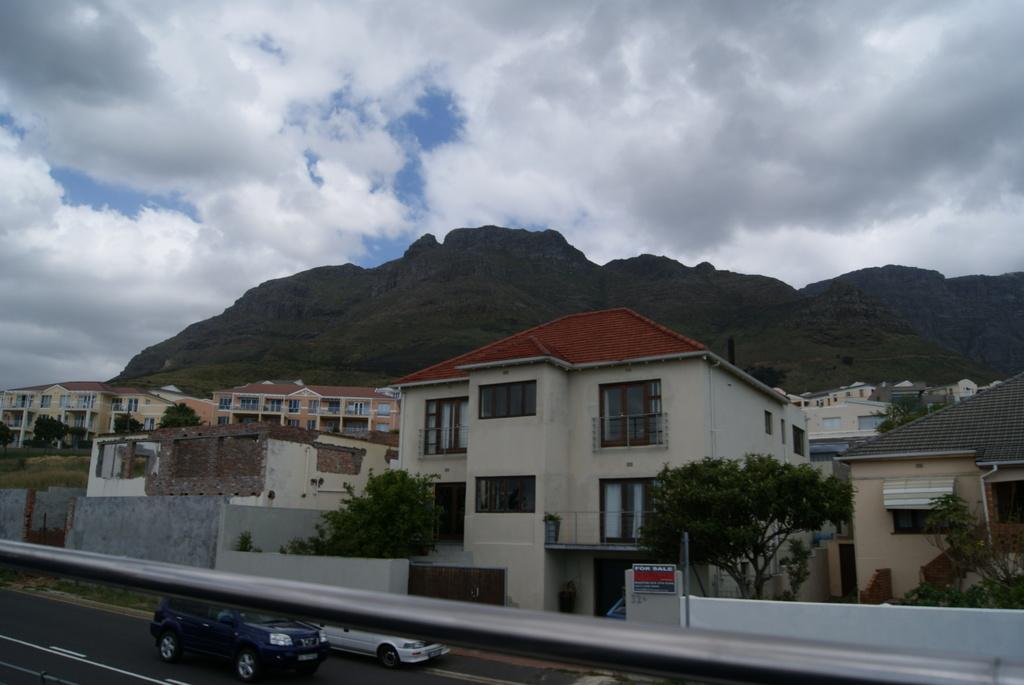Please provide a concise description of this image. In the picture I can see buildings, trees, vehicles on the road. In the background I can see mountain and the sky. 